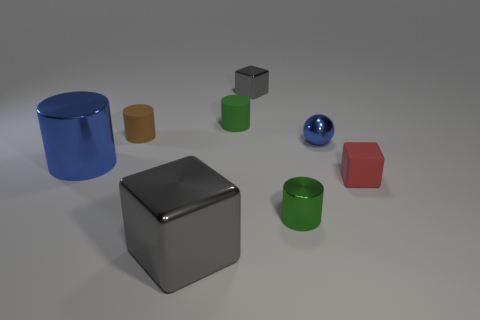Subtract 1 cylinders. How many cylinders are left? 3 Subtract all red cylinders. Subtract all purple cubes. How many cylinders are left? 4 Add 1 cylinders. How many objects exist? 9 Subtract all balls. How many objects are left? 7 Add 5 yellow balls. How many yellow balls exist? 5 Subtract 1 red cubes. How many objects are left? 7 Subtract all blue spheres. Subtract all metallic cylinders. How many objects are left? 5 Add 4 big metal cylinders. How many big metal cylinders are left? 5 